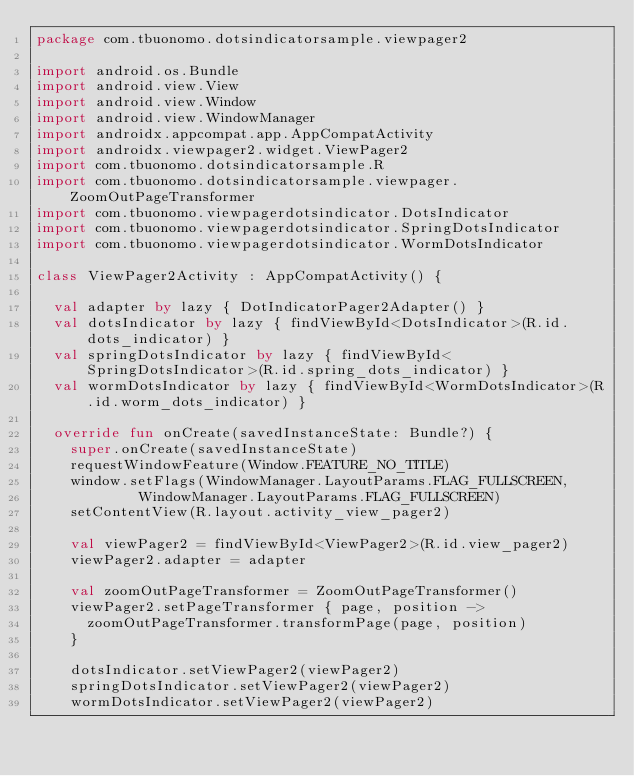<code> <loc_0><loc_0><loc_500><loc_500><_Kotlin_>package com.tbuonomo.dotsindicatorsample.viewpager2

import android.os.Bundle
import android.view.View
import android.view.Window
import android.view.WindowManager
import androidx.appcompat.app.AppCompatActivity
import androidx.viewpager2.widget.ViewPager2
import com.tbuonomo.dotsindicatorsample.R
import com.tbuonomo.dotsindicatorsample.viewpager.ZoomOutPageTransformer
import com.tbuonomo.viewpagerdotsindicator.DotsIndicator
import com.tbuonomo.viewpagerdotsindicator.SpringDotsIndicator
import com.tbuonomo.viewpagerdotsindicator.WormDotsIndicator

class ViewPager2Activity : AppCompatActivity() {

  val adapter by lazy { DotIndicatorPager2Adapter() }
  val dotsIndicator by lazy { findViewById<DotsIndicator>(R.id.dots_indicator) }
  val springDotsIndicator by lazy { findViewById<SpringDotsIndicator>(R.id.spring_dots_indicator) }
  val wormDotsIndicator by lazy { findViewById<WormDotsIndicator>(R.id.worm_dots_indicator) }

  override fun onCreate(savedInstanceState: Bundle?) {
    super.onCreate(savedInstanceState)
    requestWindowFeature(Window.FEATURE_NO_TITLE)
    window.setFlags(WindowManager.LayoutParams.FLAG_FULLSCREEN,
            WindowManager.LayoutParams.FLAG_FULLSCREEN)
    setContentView(R.layout.activity_view_pager2)

    val viewPager2 = findViewById<ViewPager2>(R.id.view_pager2)
    viewPager2.adapter = adapter

    val zoomOutPageTransformer = ZoomOutPageTransformer()
    viewPager2.setPageTransformer { page, position ->
      zoomOutPageTransformer.transformPage(page, position)
    }

    dotsIndicator.setViewPager2(viewPager2)
    springDotsIndicator.setViewPager2(viewPager2)
    wormDotsIndicator.setViewPager2(viewPager2)</code> 